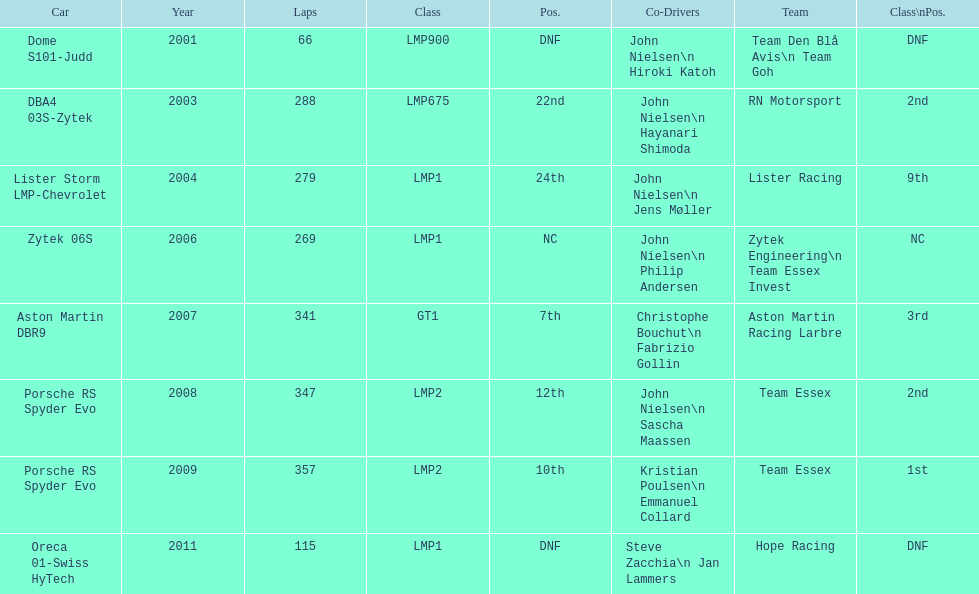In 2008 and what other year was casper elgaard on team essex for the 24 hours of le mans? 2009. 